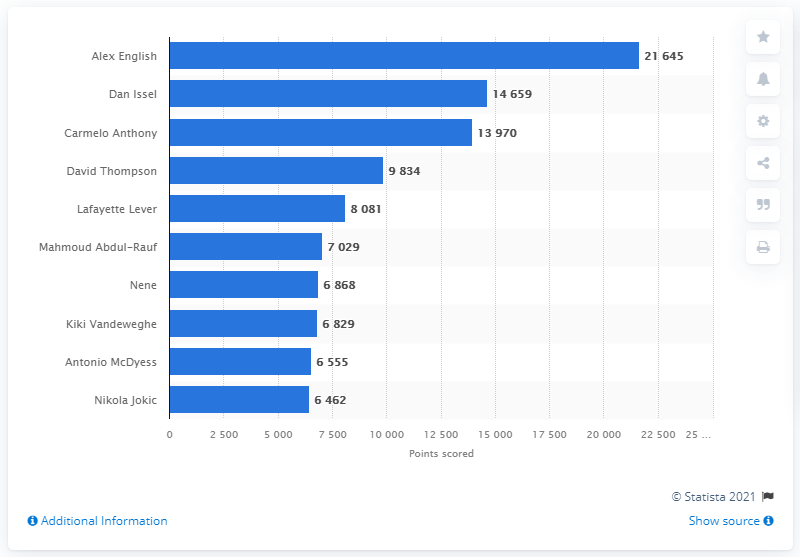Point out several critical features in this image. Alex English is the career points leader of the Denver Nuggets. 